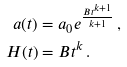Convert formula to latex. <formula><loc_0><loc_0><loc_500><loc_500>a ( t ) & = a _ { 0 } e ^ { \frac { B t ^ { k + 1 } } { k + 1 } } \, , \\ H ( t ) & = B t ^ { k } \, .</formula> 